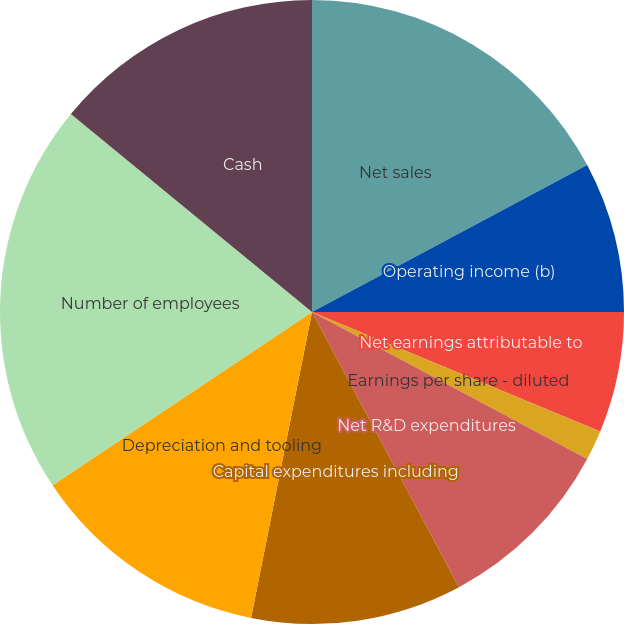Convert chart. <chart><loc_0><loc_0><loc_500><loc_500><pie_chart><fcel>Net sales<fcel>Operating income (b)<fcel>Net earnings attributable to<fcel>Earnings per share - basic (c)<fcel>Earnings per share - diluted<fcel>Net R&D expenditures<fcel>Capital expenditures including<fcel>Depreciation and tooling<fcel>Number of employees<fcel>Cash<nl><fcel>17.19%<fcel>7.81%<fcel>6.25%<fcel>0.0%<fcel>1.56%<fcel>9.38%<fcel>10.94%<fcel>12.5%<fcel>20.31%<fcel>14.06%<nl></chart> 